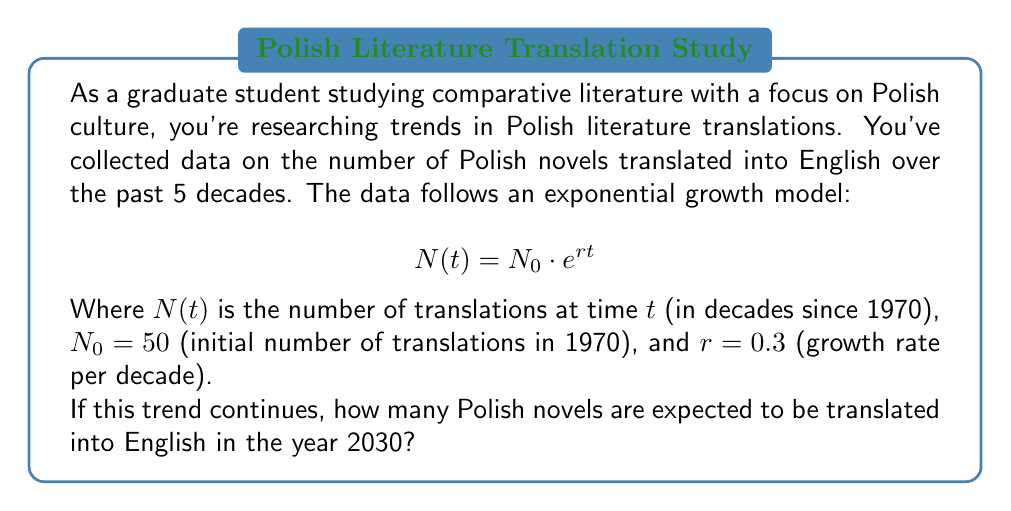Could you help me with this problem? Let's approach this step-by-step:

1) We're given the exponential growth model: $N(t) = N_0 \cdot e^{rt}$

2) We know:
   $N_0 = 50$ (initial number of translations in 1970)
   $r = 0.3$ (growth rate per decade)

3) We need to find $N(t)$ for the year 2030. First, let's calculate $t$:
   - 1970 to 2030 is 60 years
   - Since $t$ is in decades, $t = 60/10 = 6$ decades

4) Now we can plug these values into our equation:

   $N(6) = 50 \cdot e^{0.3 \cdot 6}$

5) Let's calculate this:
   $N(6) = 50 \cdot e^{1.8}$
   $N(6) = 50 \cdot 6.0496$
   $N(6) = 302.48$

6) Since we're dealing with whole books, we should round to the nearest integer:

   $N(6) \approx 302$

Therefore, if this exponential growth trend continues, approximately 302 Polish novels are expected to be translated into English by 2030.
Answer: 302 novels 